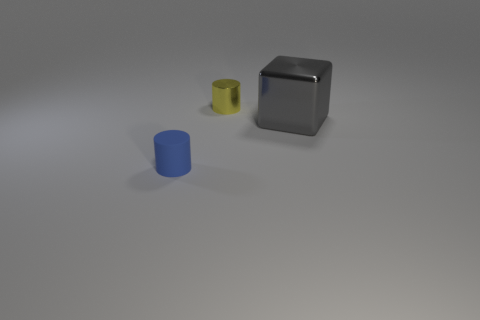Subtract all blue cylinders. How many cylinders are left? 1 Subtract all cubes. How many objects are left? 2 Subtract all cyan cylinders. Subtract all brown blocks. How many cylinders are left? 2 Add 1 gray metallic objects. How many gray metallic objects exist? 2 Add 1 small blue matte cubes. How many objects exist? 4 Subtract 1 gray cubes. How many objects are left? 2 Subtract 1 cylinders. How many cylinders are left? 1 Subtract all brown cubes. How many blue cylinders are left? 1 Subtract all big blue cubes. Subtract all cylinders. How many objects are left? 1 Add 1 blue cylinders. How many blue cylinders are left? 2 